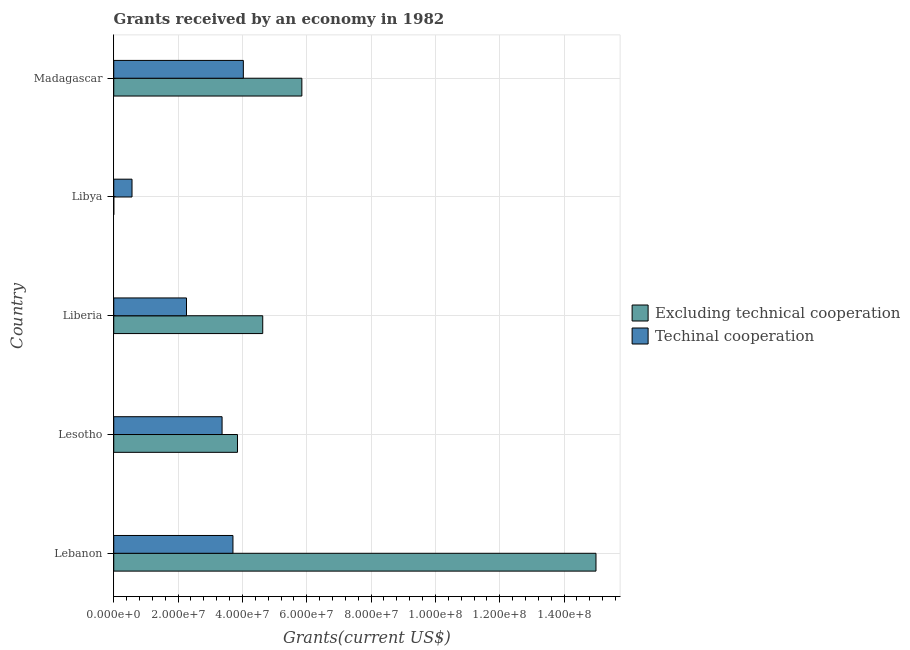How many different coloured bars are there?
Provide a short and direct response. 2. Are the number of bars per tick equal to the number of legend labels?
Provide a short and direct response. Yes. Are the number of bars on each tick of the Y-axis equal?
Your answer should be compact. Yes. How many bars are there on the 5th tick from the top?
Make the answer very short. 2. How many bars are there on the 2nd tick from the bottom?
Your response must be concise. 2. What is the label of the 2nd group of bars from the top?
Your response must be concise. Libya. What is the amount of grants received(including technical cooperation) in Lebanon?
Your response must be concise. 3.71e+07. Across all countries, what is the maximum amount of grants received(including technical cooperation)?
Offer a terse response. 4.03e+07. Across all countries, what is the minimum amount of grants received(including technical cooperation)?
Your answer should be compact. 5.68e+06. In which country was the amount of grants received(including technical cooperation) maximum?
Ensure brevity in your answer.  Madagascar. In which country was the amount of grants received(including technical cooperation) minimum?
Your answer should be compact. Libya. What is the total amount of grants received(excluding technical cooperation) in the graph?
Provide a succinct answer. 2.93e+08. What is the difference between the amount of grants received(excluding technical cooperation) in Lebanon and that in Madagascar?
Make the answer very short. 9.14e+07. What is the difference between the amount of grants received(including technical cooperation) in Lebanon and the amount of grants received(excluding technical cooperation) in Lesotho?
Ensure brevity in your answer.  -1.41e+06. What is the average amount of grants received(excluding technical cooperation) per country?
Ensure brevity in your answer.  5.86e+07. What is the difference between the amount of grants received(excluding technical cooperation) and amount of grants received(including technical cooperation) in Madagascar?
Your response must be concise. 1.82e+07. In how many countries, is the amount of grants received(excluding technical cooperation) greater than 104000000 US$?
Your answer should be very brief. 1. What is the ratio of the amount of grants received(including technical cooperation) in Libya to that in Madagascar?
Make the answer very short. 0.14. Is the amount of grants received(excluding technical cooperation) in Lesotho less than that in Libya?
Give a very brief answer. No. Is the difference between the amount of grants received(excluding technical cooperation) in Lesotho and Madagascar greater than the difference between the amount of grants received(including technical cooperation) in Lesotho and Madagascar?
Provide a short and direct response. No. What is the difference between the highest and the second highest amount of grants received(excluding technical cooperation)?
Your answer should be very brief. 9.14e+07. What is the difference between the highest and the lowest amount of grants received(excluding technical cooperation)?
Offer a terse response. 1.50e+08. In how many countries, is the amount of grants received(excluding technical cooperation) greater than the average amount of grants received(excluding technical cooperation) taken over all countries?
Make the answer very short. 1. What does the 1st bar from the top in Liberia represents?
Keep it short and to the point. Techinal cooperation. What does the 1st bar from the bottom in Liberia represents?
Your answer should be compact. Excluding technical cooperation. How many bars are there?
Your answer should be very brief. 10. How many countries are there in the graph?
Provide a succinct answer. 5. Are the values on the major ticks of X-axis written in scientific E-notation?
Provide a succinct answer. Yes. Does the graph contain grids?
Give a very brief answer. Yes. How many legend labels are there?
Give a very brief answer. 2. How are the legend labels stacked?
Provide a succinct answer. Vertical. What is the title of the graph?
Provide a short and direct response. Grants received by an economy in 1982. What is the label or title of the X-axis?
Provide a short and direct response. Grants(current US$). What is the label or title of the Y-axis?
Offer a very short reply. Country. What is the Grants(current US$) of Excluding technical cooperation in Lebanon?
Offer a terse response. 1.50e+08. What is the Grants(current US$) in Techinal cooperation in Lebanon?
Give a very brief answer. 3.71e+07. What is the Grants(current US$) of Excluding technical cooperation in Lesotho?
Provide a short and direct response. 3.85e+07. What is the Grants(current US$) in Techinal cooperation in Lesotho?
Ensure brevity in your answer.  3.37e+07. What is the Grants(current US$) in Excluding technical cooperation in Liberia?
Offer a very short reply. 4.63e+07. What is the Grants(current US$) in Techinal cooperation in Liberia?
Your response must be concise. 2.26e+07. What is the Grants(current US$) in Excluding technical cooperation in Libya?
Provide a succinct answer. 1.00e+04. What is the Grants(current US$) in Techinal cooperation in Libya?
Offer a terse response. 5.68e+06. What is the Grants(current US$) of Excluding technical cooperation in Madagascar?
Your response must be concise. 5.85e+07. What is the Grants(current US$) of Techinal cooperation in Madagascar?
Your response must be concise. 4.03e+07. Across all countries, what is the maximum Grants(current US$) in Excluding technical cooperation?
Offer a terse response. 1.50e+08. Across all countries, what is the maximum Grants(current US$) in Techinal cooperation?
Make the answer very short. 4.03e+07. Across all countries, what is the minimum Grants(current US$) in Excluding technical cooperation?
Your answer should be very brief. 1.00e+04. Across all countries, what is the minimum Grants(current US$) in Techinal cooperation?
Your response must be concise. 5.68e+06. What is the total Grants(current US$) of Excluding technical cooperation in the graph?
Keep it short and to the point. 2.93e+08. What is the total Grants(current US$) of Techinal cooperation in the graph?
Your answer should be compact. 1.39e+08. What is the difference between the Grants(current US$) in Excluding technical cooperation in Lebanon and that in Lesotho?
Ensure brevity in your answer.  1.11e+08. What is the difference between the Grants(current US$) of Techinal cooperation in Lebanon and that in Lesotho?
Provide a succinct answer. 3.38e+06. What is the difference between the Grants(current US$) in Excluding technical cooperation in Lebanon and that in Liberia?
Make the answer very short. 1.04e+08. What is the difference between the Grants(current US$) in Techinal cooperation in Lebanon and that in Liberia?
Keep it short and to the point. 1.44e+07. What is the difference between the Grants(current US$) in Excluding technical cooperation in Lebanon and that in Libya?
Make the answer very short. 1.50e+08. What is the difference between the Grants(current US$) of Techinal cooperation in Lebanon and that in Libya?
Make the answer very short. 3.14e+07. What is the difference between the Grants(current US$) of Excluding technical cooperation in Lebanon and that in Madagascar?
Ensure brevity in your answer.  9.14e+07. What is the difference between the Grants(current US$) in Techinal cooperation in Lebanon and that in Madagascar?
Offer a terse response. -3.23e+06. What is the difference between the Grants(current US$) in Excluding technical cooperation in Lesotho and that in Liberia?
Make the answer very short. -7.85e+06. What is the difference between the Grants(current US$) in Techinal cooperation in Lesotho and that in Liberia?
Provide a short and direct response. 1.11e+07. What is the difference between the Grants(current US$) of Excluding technical cooperation in Lesotho and that in Libya?
Keep it short and to the point. 3.85e+07. What is the difference between the Grants(current US$) of Techinal cooperation in Lesotho and that in Libya?
Your answer should be very brief. 2.80e+07. What is the difference between the Grants(current US$) of Excluding technical cooperation in Lesotho and that in Madagascar?
Give a very brief answer. -2.00e+07. What is the difference between the Grants(current US$) of Techinal cooperation in Lesotho and that in Madagascar?
Make the answer very short. -6.61e+06. What is the difference between the Grants(current US$) of Excluding technical cooperation in Liberia and that in Libya?
Make the answer very short. 4.63e+07. What is the difference between the Grants(current US$) in Techinal cooperation in Liberia and that in Libya?
Give a very brief answer. 1.69e+07. What is the difference between the Grants(current US$) of Excluding technical cooperation in Liberia and that in Madagascar?
Give a very brief answer. -1.22e+07. What is the difference between the Grants(current US$) of Techinal cooperation in Liberia and that in Madagascar?
Ensure brevity in your answer.  -1.77e+07. What is the difference between the Grants(current US$) of Excluding technical cooperation in Libya and that in Madagascar?
Ensure brevity in your answer.  -5.85e+07. What is the difference between the Grants(current US$) of Techinal cooperation in Libya and that in Madagascar?
Keep it short and to the point. -3.46e+07. What is the difference between the Grants(current US$) of Excluding technical cooperation in Lebanon and the Grants(current US$) of Techinal cooperation in Lesotho?
Provide a short and direct response. 1.16e+08. What is the difference between the Grants(current US$) in Excluding technical cooperation in Lebanon and the Grants(current US$) in Techinal cooperation in Liberia?
Provide a short and direct response. 1.27e+08. What is the difference between the Grants(current US$) of Excluding technical cooperation in Lebanon and the Grants(current US$) of Techinal cooperation in Libya?
Ensure brevity in your answer.  1.44e+08. What is the difference between the Grants(current US$) of Excluding technical cooperation in Lebanon and the Grants(current US$) of Techinal cooperation in Madagascar?
Keep it short and to the point. 1.10e+08. What is the difference between the Grants(current US$) of Excluding technical cooperation in Lesotho and the Grants(current US$) of Techinal cooperation in Liberia?
Your answer should be compact. 1.58e+07. What is the difference between the Grants(current US$) of Excluding technical cooperation in Lesotho and the Grants(current US$) of Techinal cooperation in Libya?
Your response must be concise. 3.28e+07. What is the difference between the Grants(current US$) of Excluding technical cooperation in Lesotho and the Grants(current US$) of Techinal cooperation in Madagascar?
Give a very brief answer. -1.82e+06. What is the difference between the Grants(current US$) of Excluding technical cooperation in Liberia and the Grants(current US$) of Techinal cooperation in Libya?
Ensure brevity in your answer.  4.06e+07. What is the difference between the Grants(current US$) of Excluding technical cooperation in Liberia and the Grants(current US$) of Techinal cooperation in Madagascar?
Ensure brevity in your answer.  6.03e+06. What is the difference between the Grants(current US$) in Excluding technical cooperation in Libya and the Grants(current US$) in Techinal cooperation in Madagascar?
Offer a terse response. -4.03e+07. What is the average Grants(current US$) of Excluding technical cooperation per country?
Your answer should be compact. 5.86e+07. What is the average Grants(current US$) of Techinal cooperation per country?
Provide a short and direct response. 2.79e+07. What is the difference between the Grants(current US$) in Excluding technical cooperation and Grants(current US$) in Techinal cooperation in Lebanon?
Your response must be concise. 1.13e+08. What is the difference between the Grants(current US$) of Excluding technical cooperation and Grants(current US$) of Techinal cooperation in Lesotho?
Ensure brevity in your answer.  4.79e+06. What is the difference between the Grants(current US$) in Excluding technical cooperation and Grants(current US$) in Techinal cooperation in Liberia?
Your answer should be very brief. 2.37e+07. What is the difference between the Grants(current US$) of Excluding technical cooperation and Grants(current US$) of Techinal cooperation in Libya?
Keep it short and to the point. -5.67e+06. What is the difference between the Grants(current US$) of Excluding technical cooperation and Grants(current US$) of Techinal cooperation in Madagascar?
Offer a terse response. 1.82e+07. What is the ratio of the Grants(current US$) of Excluding technical cooperation in Lebanon to that in Lesotho?
Make the answer very short. 3.9. What is the ratio of the Grants(current US$) of Techinal cooperation in Lebanon to that in Lesotho?
Provide a succinct answer. 1.1. What is the ratio of the Grants(current US$) of Excluding technical cooperation in Lebanon to that in Liberia?
Ensure brevity in your answer.  3.24. What is the ratio of the Grants(current US$) in Techinal cooperation in Lebanon to that in Liberia?
Offer a very short reply. 1.64. What is the ratio of the Grants(current US$) of Excluding technical cooperation in Lebanon to that in Libya?
Ensure brevity in your answer.  1.50e+04. What is the ratio of the Grants(current US$) of Techinal cooperation in Lebanon to that in Libya?
Provide a short and direct response. 6.52. What is the ratio of the Grants(current US$) in Excluding technical cooperation in Lebanon to that in Madagascar?
Provide a succinct answer. 2.56. What is the ratio of the Grants(current US$) in Techinal cooperation in Lebanon to that in Madagascar?
Your answer should be very brief. 0.92. What is the ratio of the Grants(current US$) in Excluding technical cooperation in Lesotho to that in Liberia?
Offer a very short reply. 0.83. What is the ratio of the Grants(current US$) of Techinal cooperation in Lesotho to that in Liberia?
Offer a terse response. 1.49. What is the ratio of the Grants(current US$) in Excluding technical cooperation in Lesotho to that in Libya?
Your response must be concise. 3847. What is the ratio of the Grants(current US$) in Techinal cooperation in Lesotho to that in Libya?
Make the answer very short. 5.93. What is the ratio of the Grants(current US$) of Excluding technical cooperation in Lesotho to that in Madagascar?
Your answer should be very brief. 0.66. What is the ratio of the Grants(current US$) in Techinal cooperation in Lesotho to that in Madagascar?
Your answer should be very brief. 0.84. What is the ratio of the Grants(current US$) of Excluding technical cooperation in Liberia to that in Libya?
Offer a terse response. 4632. What is the ratio of the Grants(current US$) in Techinal cooperation in Liberia to that in Libya?
Your answer should be compact. 3.98. What is the ratio of the Grants(current US$) of Excluding technical cooperation in Liberia to that in Madagascar?
Make the answer very short. 0.79. What is the ratio of the Grants(current US$) in Techinal cooperation in Liberia to that in Madagascar?
Provide a succinct answer. 0.56. What is the ratio of the Grants(current US$) of Techinal cooperation in Libya to that in Madagascar?
Offer a very short reply. 0.14. What is the difference between the highest and the second highest Grants(current US$) in Excluding technical cooperation?
Give a very brief answer. 9.14e+07. What is the difference between the highest and the second highest Grants(current US$) in Techinal cooperation?
Provide a short and direct response. 3.23e+06. What is the difference between the highest and the lowest Grants(current US$) of Excluding technical cooperation?
Provide a succinct answer. 1.50e+08. What is the difference between the highest and the lowest Grants(current US$) of Techinal cooperation?
Ensure brevity in your answer.  3.46e+07. 